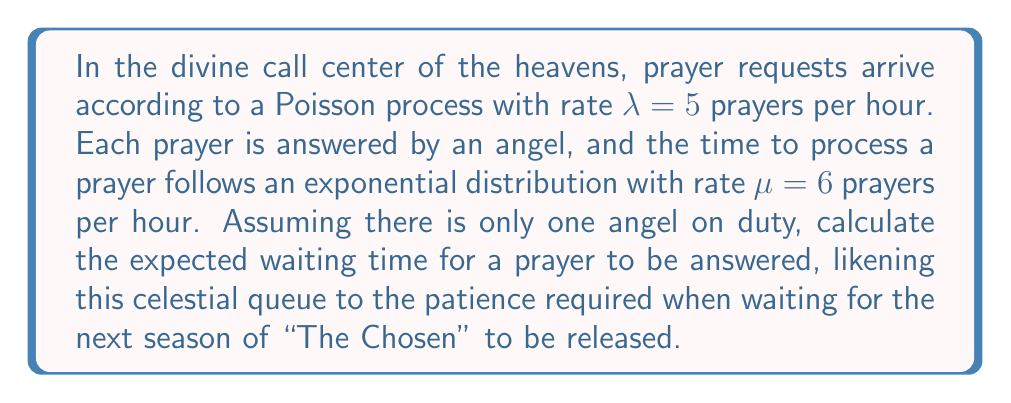Help me with this question. To solve this problem, we'll use the M/M/1 queuing model, where:
M: Markovian arrival process (Poisson)
M: Markovian service times (Exponential)
1: Single server (one angel)

Step 1: Calculate the utilization factor $\rho$
$$\rho = \frac{\lambda}{\mu} = \frac{5}{6} \approx 0.833$$

Step 2: Calculate the expected number of prayers in the system (L)
$$L = \frac{\rho}{1-\rho} = \frac{5/6}{1-5/6} = 5$$

Step 3: Apply Little's Law to find the expected time in the system (W)
$$W = \frac{L}{\lambda} = \frac{5}{5} = 1 \text{ hour}$$

Step 4: Calculate the expected service time (S)
$$S = \frac{1}{\mu} = \frac{1}{6} \text{ hour}$$

Step 5: Calculate the expected waiting time (Wq)
$$W_q = W - S = 1 - \frac{1}{6} = \frac{5}{6} \text{ hour}$$

Therefore, the expected waiting time for a prayer to be answered is $\frac{5}{6}$ hour or 50 minutes.
Answer: $\frac{5}{6}$ hour 